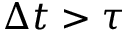Convert formula to latex. <formula><loc_0><loc_0><loc_500><loc_500>\Delta t > \tau</formula> 